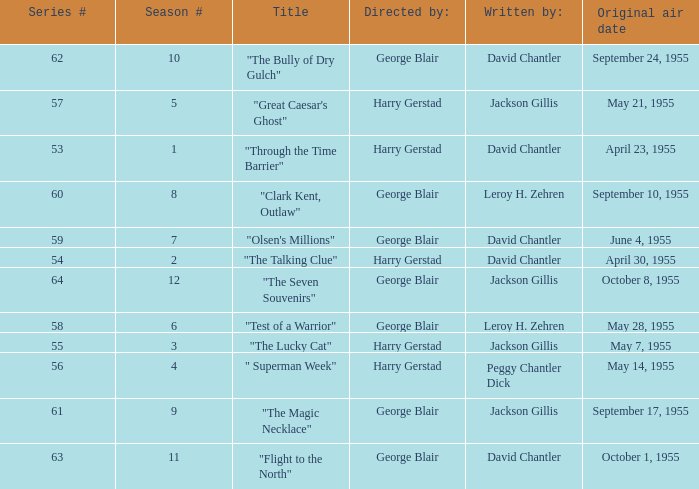Who directed the episode that was written by Jackson Gillis and Originally aired on May 21, 1955? Harry Gerstad. 